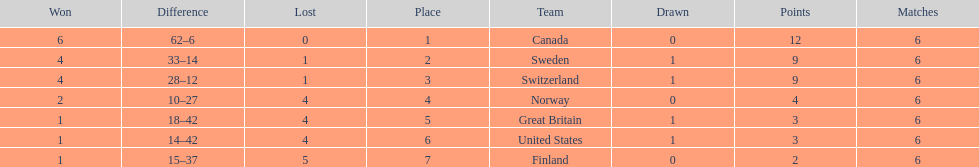How many teams won at least 2 games throughout the 1951 world ice hockey championships? 4. 